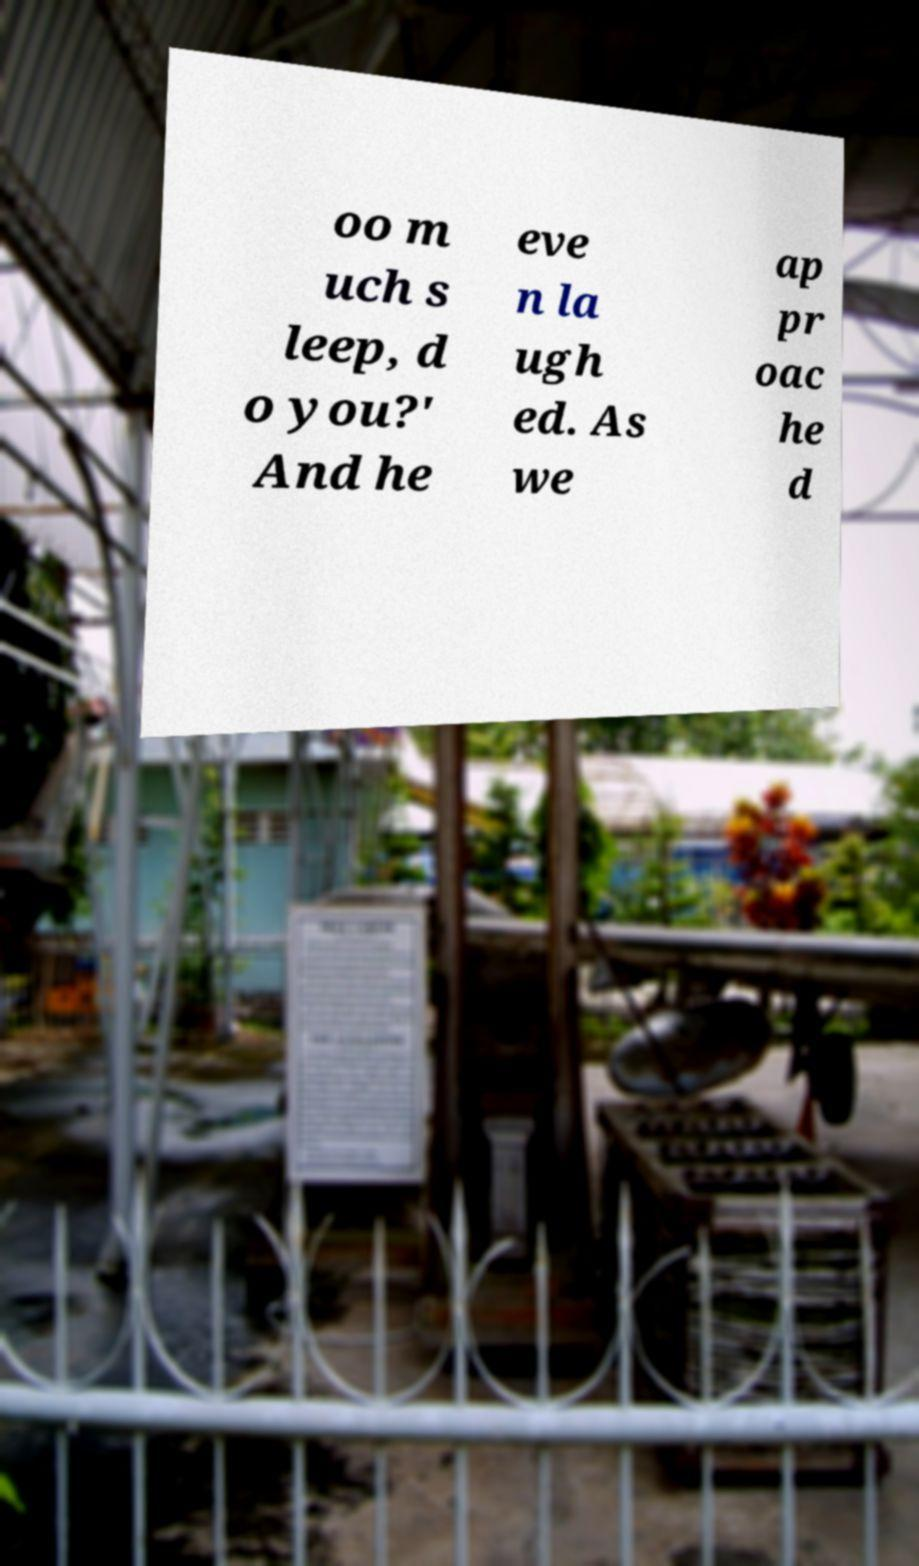Please read and relay the text visible in this image. What does it say? oo m uch s leep, d o you?' And he eve n la ugh ed. As we ap pr oac he d 